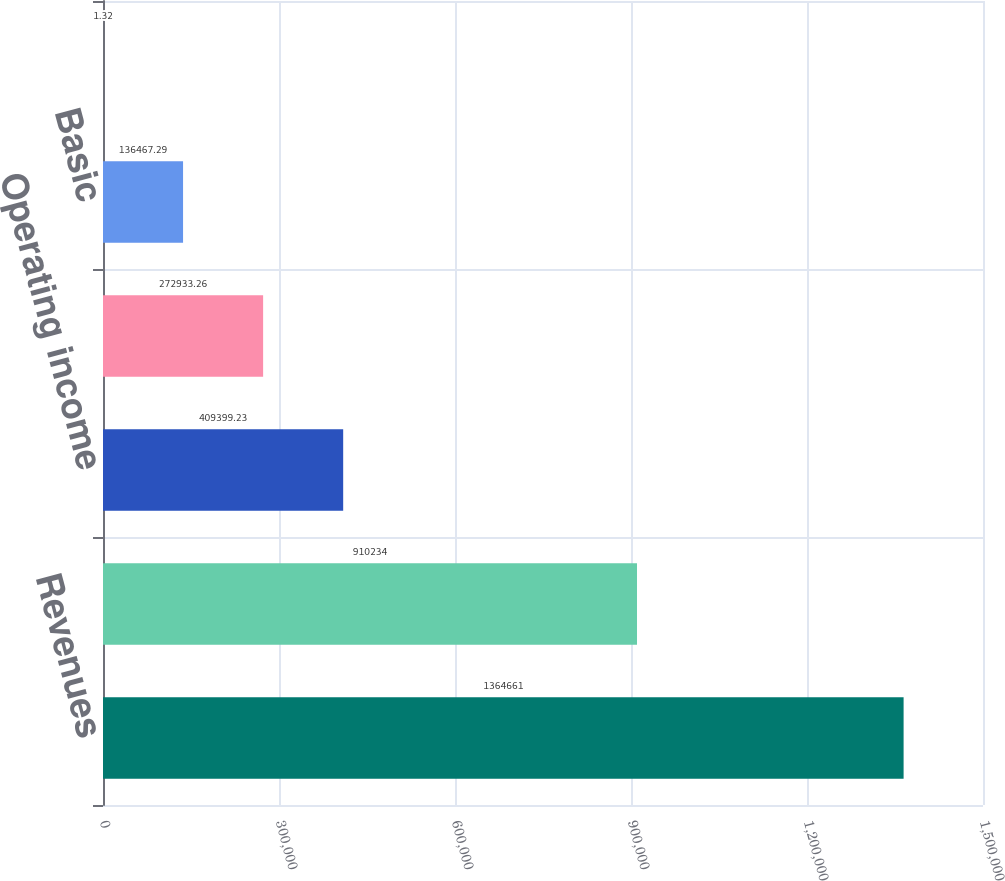<chart> <loc_0><loc_0><loc_500><loc_500><bar_chart><fcel>Revenues<fcel>Total cost of revenues<fcel>Operating income<fcel>Net income<fcel>Basic<fcel>Diluted<nl><fcel>1.36466e+06<fcel>910234<fcel>409399<fcel>272933<fcel>136467<fcel>1.32<nl></chart> 